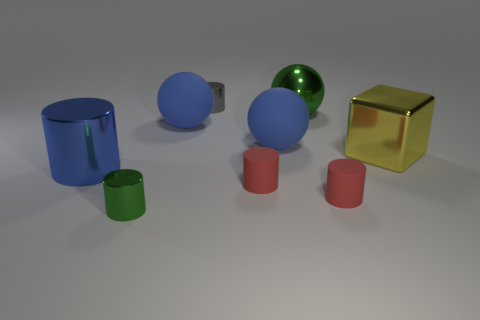Is there anything else that has the same size as the block?
Keep it short and to the point. Yes. There is a green thing in front of the big metal cylinder; does it have the same shape as the large yellow object?
Give a very brief answer. No. Are there more small objects that are behind the big green metal thing than gray objects?
Provide a succinct answer. No. What is the color of the tiny metal object behind the tiny cylinder that is right of the green metal ball?
Give a very brief answer. Gray. What number of balls are there?
Provide a succinct answer. 3. How many things are in front of the blue shiny object and to the left of the gray metal object?
Make the answer very short. 1. Are there any other things that are the same shape as the big green thing?
Your answer should be compact. Yes. Do the large metal cube and the metal cylinder that is in front of the big shiny cylinder have the same color?
Ensure brevity in your answer.  No. What shape is the large blue matte thing right of the gray shiny cylinder?
Ensure brevity in your answer.  Sphere. How many other things are the same material as the large cylinder?
Offer a terse response. 4. 